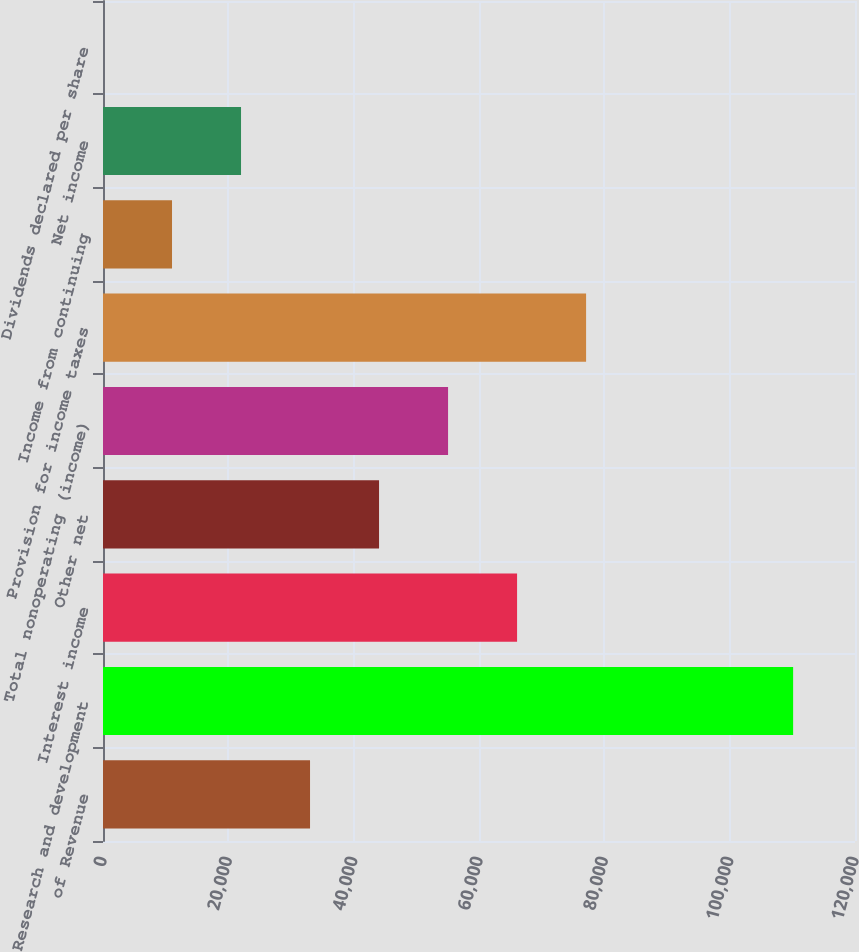<chart> <loc_0><loc_0><loc_500><loc_500><bar_chart><fcel>of Revenue<fcel>Research and development<fcel>Interest income<fcel>Other net<fcel>Total nonoperating (income)<fcel>Provision for income taxes<fcel>Income from continuing<fcel>Net income<fcel>Dividends declared per share<nl><fcel>33037.9<fcel>110126<fcel>66075.7<fcel>44050.5<fcel>55063.1<fcel>77088.3<fcel>11012.8<fcel>22025.4<fcel>0.2<nl></chart> 